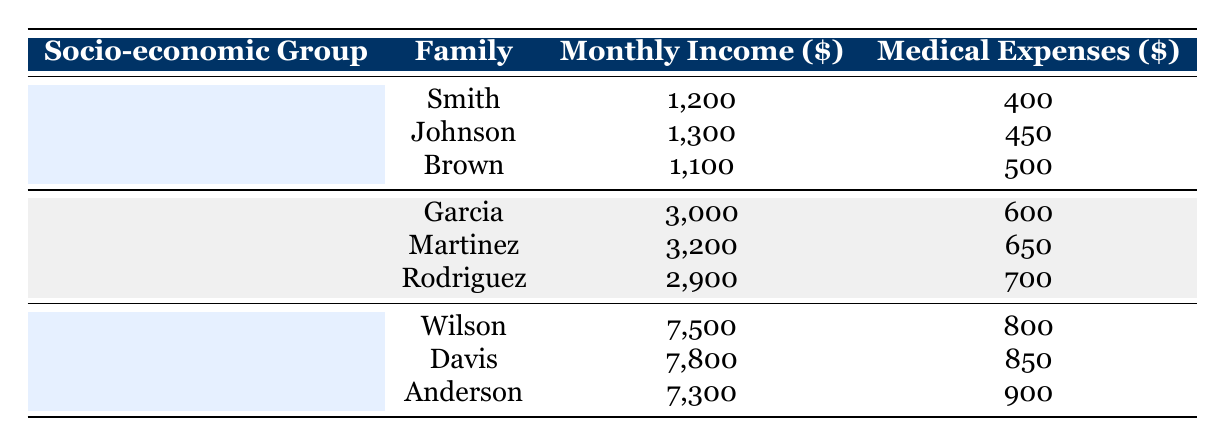What is the monthly income of the Johnson family? The table lists the families under each socio-economic group. Looking under the "Low Income" group, the Johnson family's monthly income is specifically noted. Therefore, the monthly income for the Johnson family is 1300 USD.
Answer: 1300 What are the medical expenses for the Brown family? By referencing the "Low Income" section of the table, we can see that the Brown family's medical expenses are listed directly beneath their name. The specific amount for the Brown family is 500 USD.
Answer: 500 What is the total monthly income of the families in the Middle Income group? To find the total monthly income, we add the monthly incomes of all families within the Middle Income group as follows: 3000 + 3200 + 2900 = 9100 USD. This gives us the total monthly income for that group.
Answer: 9100 How much higher is the medical expense for the Davis family compared to the Smith family? The Davis family's medical expenses are 850 USD, and the Smith family's medical expenses are 400 USD. To find the difference, we subtract the Smith family's expenses from those of the Davis family: 850 - 400 = 450 USD.
Answer: 450 Is there any family in the High Income group whose medical expenses exceed 900 USD? Checking the "High Income" section of the table, we can observe the medical expenses for each family. The Anderson family has expenses of 900 USD, which meets but does not exceed that figure. Therefore, no family has medical expenses exceeding 900 USD.
Answer: No What is the average medical expense for families in the Low Income group? For the average, we first sum the medical expenses of the families in the Low Income group: 400 + 450 + 500 = 1350 USD. There are three families, so we divide the total by three: 1350 / 3 = 450 USD. This gives us the average medical expense for that group.
Answer: 450 Which socio-economic group has the highest average monthly income? We calculate the average monthly income for all three groups. Low Income: (1200 + 1300 + 1100) / 3 = 1200; Middle Income: (3000 + 3200 + 2900) / 3 = 3033.33; High Income: (7500 + 7800 + 7300) / 3 = 7533.33. Comparing these averages, the High Income group has the highest average monthly income at 7533.33 USD.
Answer: High Income Are the medical expenses for all families in the high-income category higher than the average medical expenses of the middle-income families? The average medical expenses for the middle-income group: (600 + 650 + 700) / 3 = 650 USD. The medical expenses for the high-income families are 800, 850, and 900 USD, all of which exceed 650 USD. Therefore, the statement is true.
Answer: Yes 